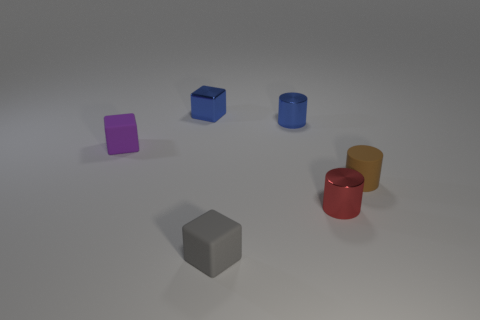What number of other objects are the same color as the shiny block?
Provide a short and direct response. 1. Is the number of small red metal objects that are behind the brown matte cylinder less than the number of red metal cylinders?
Offer a very short reply. Yes. Is there any other thing that is the same shape as the tiny purple rubber thing?
Your answer should be compact. Yes. The other metallic thing that is the same shape as the gray object is what color?
Ensure brevity in your answer.  Blue. There is a block that is in front of the red metal object; does it have the same size as the red object?
Offer a very short reply. Yes. What is the size of the rubber object that is in front of the shiny cylinder in front of the brown object?
Make the answer very short. Small. Does the purple object have the same material as the tiny cylinder that is behind the small purple thing?
Offer a very short reply. No. Is the number of blocks that are on the left side of the red cylinder less than the number of small purple cubes that are behind the tiny blue cylinder?
Keep it short and to the point. No. The cube that is made of the same material as the red cylinder is what color?
Offer a terse response. Blue. There is a cylinder that is in front of the brown matte object; is there a object left of it?
Make the answer very short. Yes. 